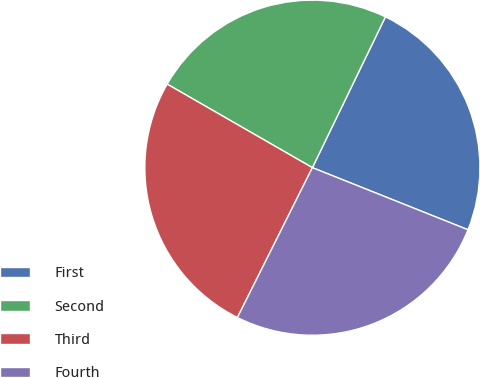<chart> <loc_0><loc_0><loc_500><loc_500><pie_chart><fcel>First<fcel>Second<fcel>Third<fcel>Fourth<nl><fcel>23.87%<fcel>23.87%<fcel>25.93%<fcel>26.34%<nl></chart> 